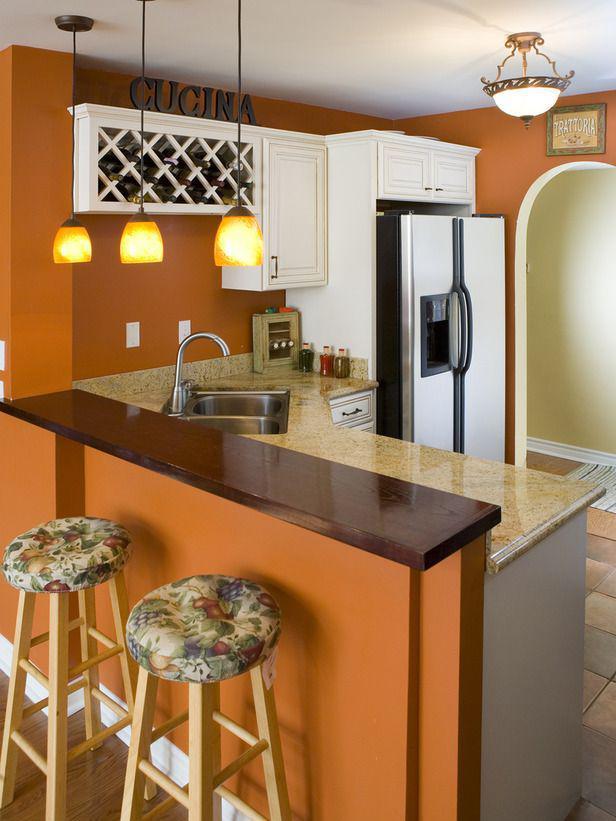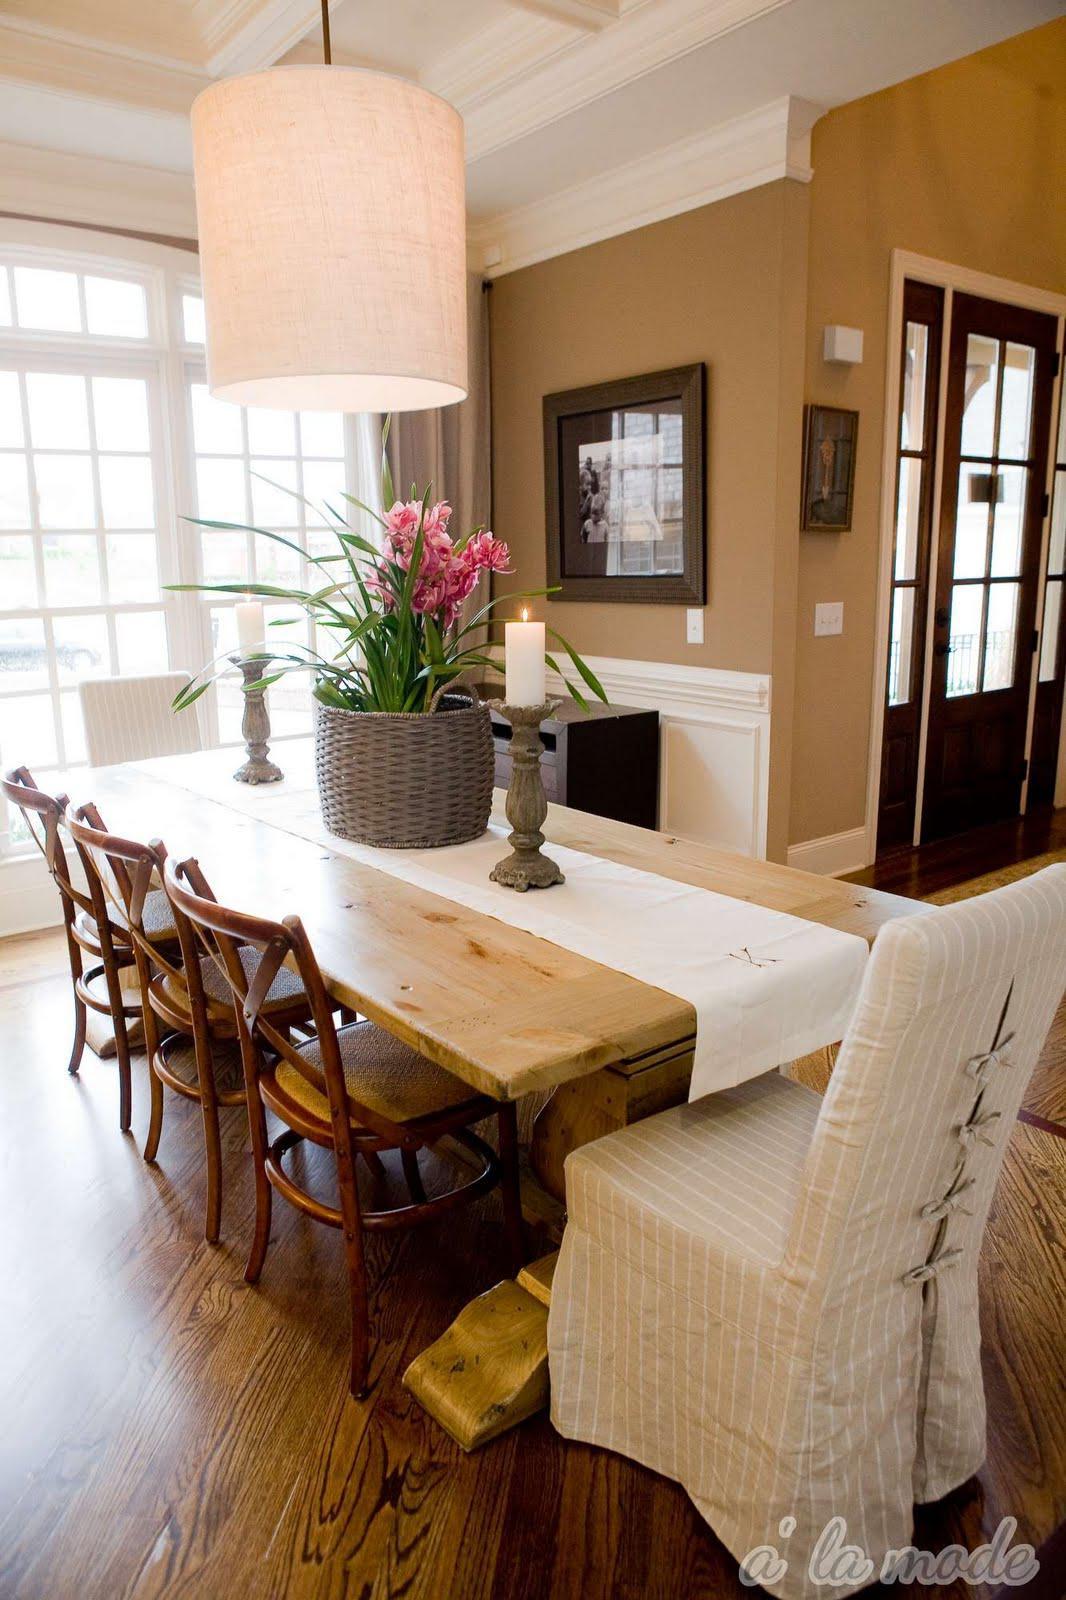The first image is the image on the left, the second image is the image on the right. Analyze the images presented: Is the assertion "In at least one image there are three hanging light over a kitchen island." valid? Answer yes or no. Yes. The first image is the image on the left, the second image is the image on the right. Considering the images on both sides, is "The left image features two bar stools pulled up to a counter with three lights hanging over it." valid? Answer yes or no. Yes. 